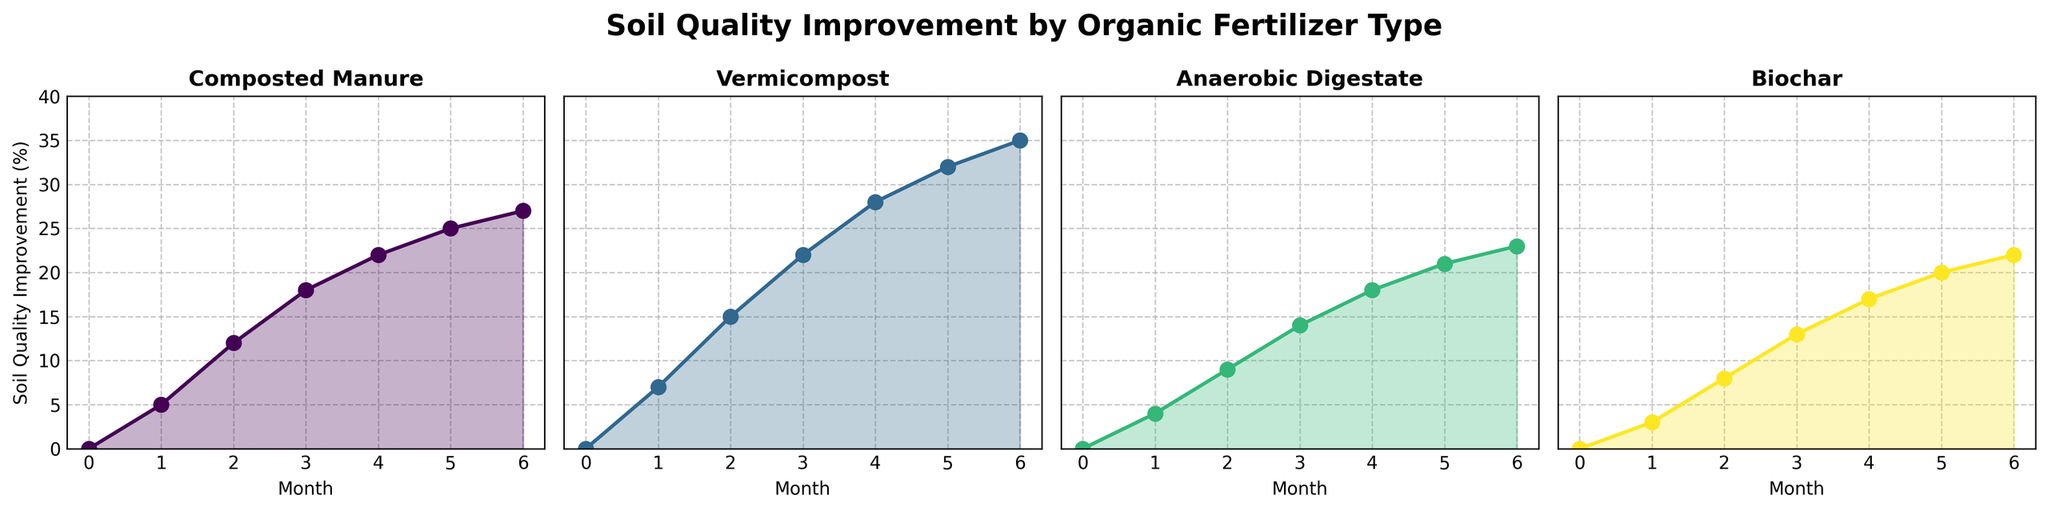How many months does it take for Vermicompost to reach and surpass 20% soil quality improvement? To determine this, we need to look at the data from the plot for Vermicompost and see at which month the soil quality improvement exceeds 20%. According to the visual, Vermicompost's soil quality improvement exceeds 20% between month 3 (22%) and month 4 (28%).
Answer: 3 months Which fertilizer type shows the quickest increase in soil quality improvement in the first month? By examining the plot, we can see the initial data points and the corresponding rises. Vermicompost showed the highest increase from 0% to 7% within the first month.
Answer: Vermicompost Between Anaerobic Digestate and Biochar, which one has a higher soil quality improvement after 6 months? By comparing the endpoints at month 6 on the plots for Anaerobic Digestate and Biochar, Anaerobic Digestate ends at 23%, whereas Biochar ends at 22%.
Answer: Anaerobic Digestate What is the difference in soil quality improvement between Composted Manure and Biochar at month 4? From the plot, Composted Manure at month 4 is at 22% and Biochar at the same time is at 17%. Subtract the smaller value from the larger value to get the difference: 22% - 17% = 5%.
Answer: 5% What is the average soil quality improvement across all fertilizer types at month 6? First, obtain the soil quality improvement values for each fertilizer type at month 6: Composted Manure (27%), Vermicompost (35%), Anaerobic Digestate (23%), and Biochar (22%). Sum these values: 27 + 35 + 23 + 22 = 107. Then, divide by the number of fertilizer types (4): 107 / 4 = 26.75%.
Answer: 26.75% Which fertilizer type shows the most consistent monthly improvement trend through the 6 months? By visually analyzing the slopes and variations of the lines, Anaerobic Digestate has a relatively steady slope without sharp changes, indicating a consistent improvement.
Answer: Anaerobic Digestate How many fertilizer types improve soil quality beyond 25% by month 5? Referring to the plot, Composted Manure (25%), Vermicompost (32%), and Anaerobic Digestate (21%), and Biochar (20%) can be seen. Only Composted Manure and Vermicompost have more than 25% improvement by month 5.
Answer: 2 